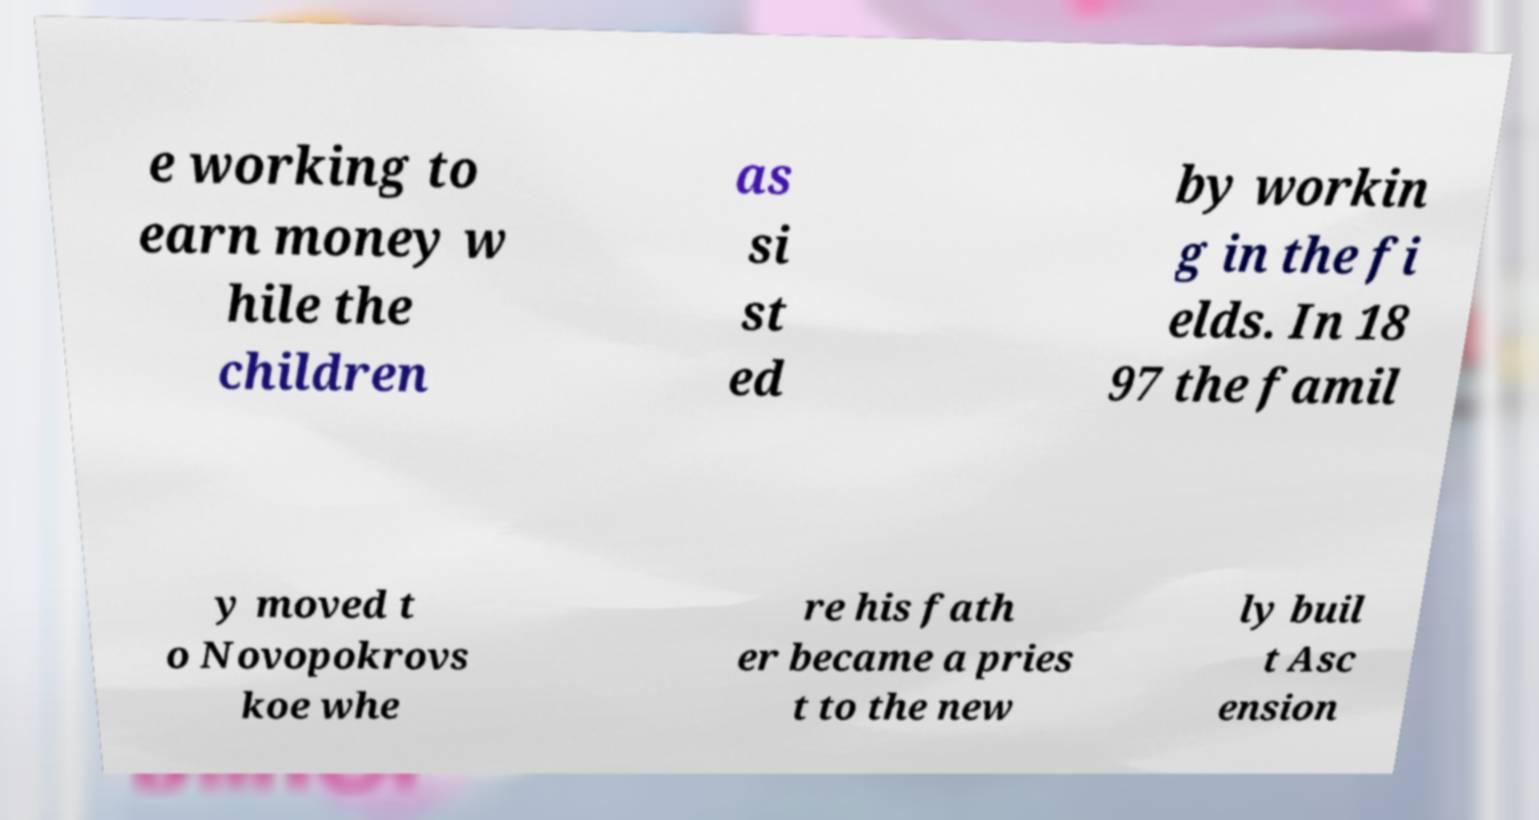Can you read and provide the text displayed in the image?This photo seems to have some interesting text. Can you extract and type it out for me? e working to earn money w hile the children as si st ed by workin g in the fi elds. In 18 97 the famil y moved t o Novopokrovs koe whe re his fath er became a pries t to the new ly buil t Asc ension 